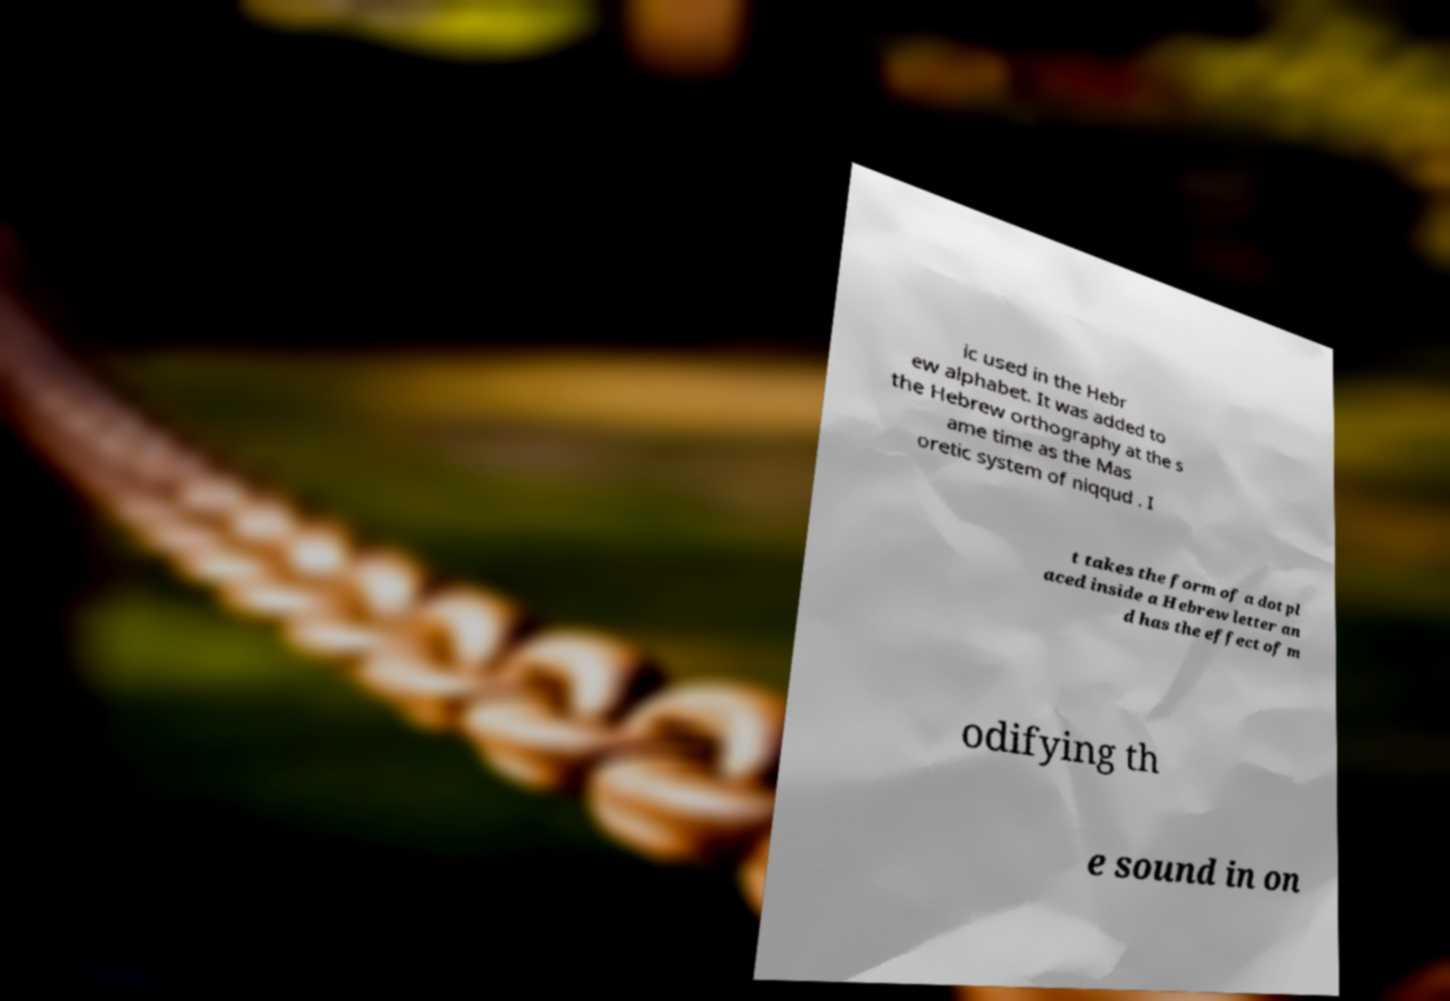Can you read and provide the text displayed in the image?This photo seems to have some interesting text. Can you extract and type it out for me? ic used in the Hebr ew alphabet. It was added to the Hebrew orthography at the s ame time as the Mas oretic system of niqqud . I t takes the form of a dot pl aced inside a Hebrew letter an d has the effect of m odifying th e sound in on 